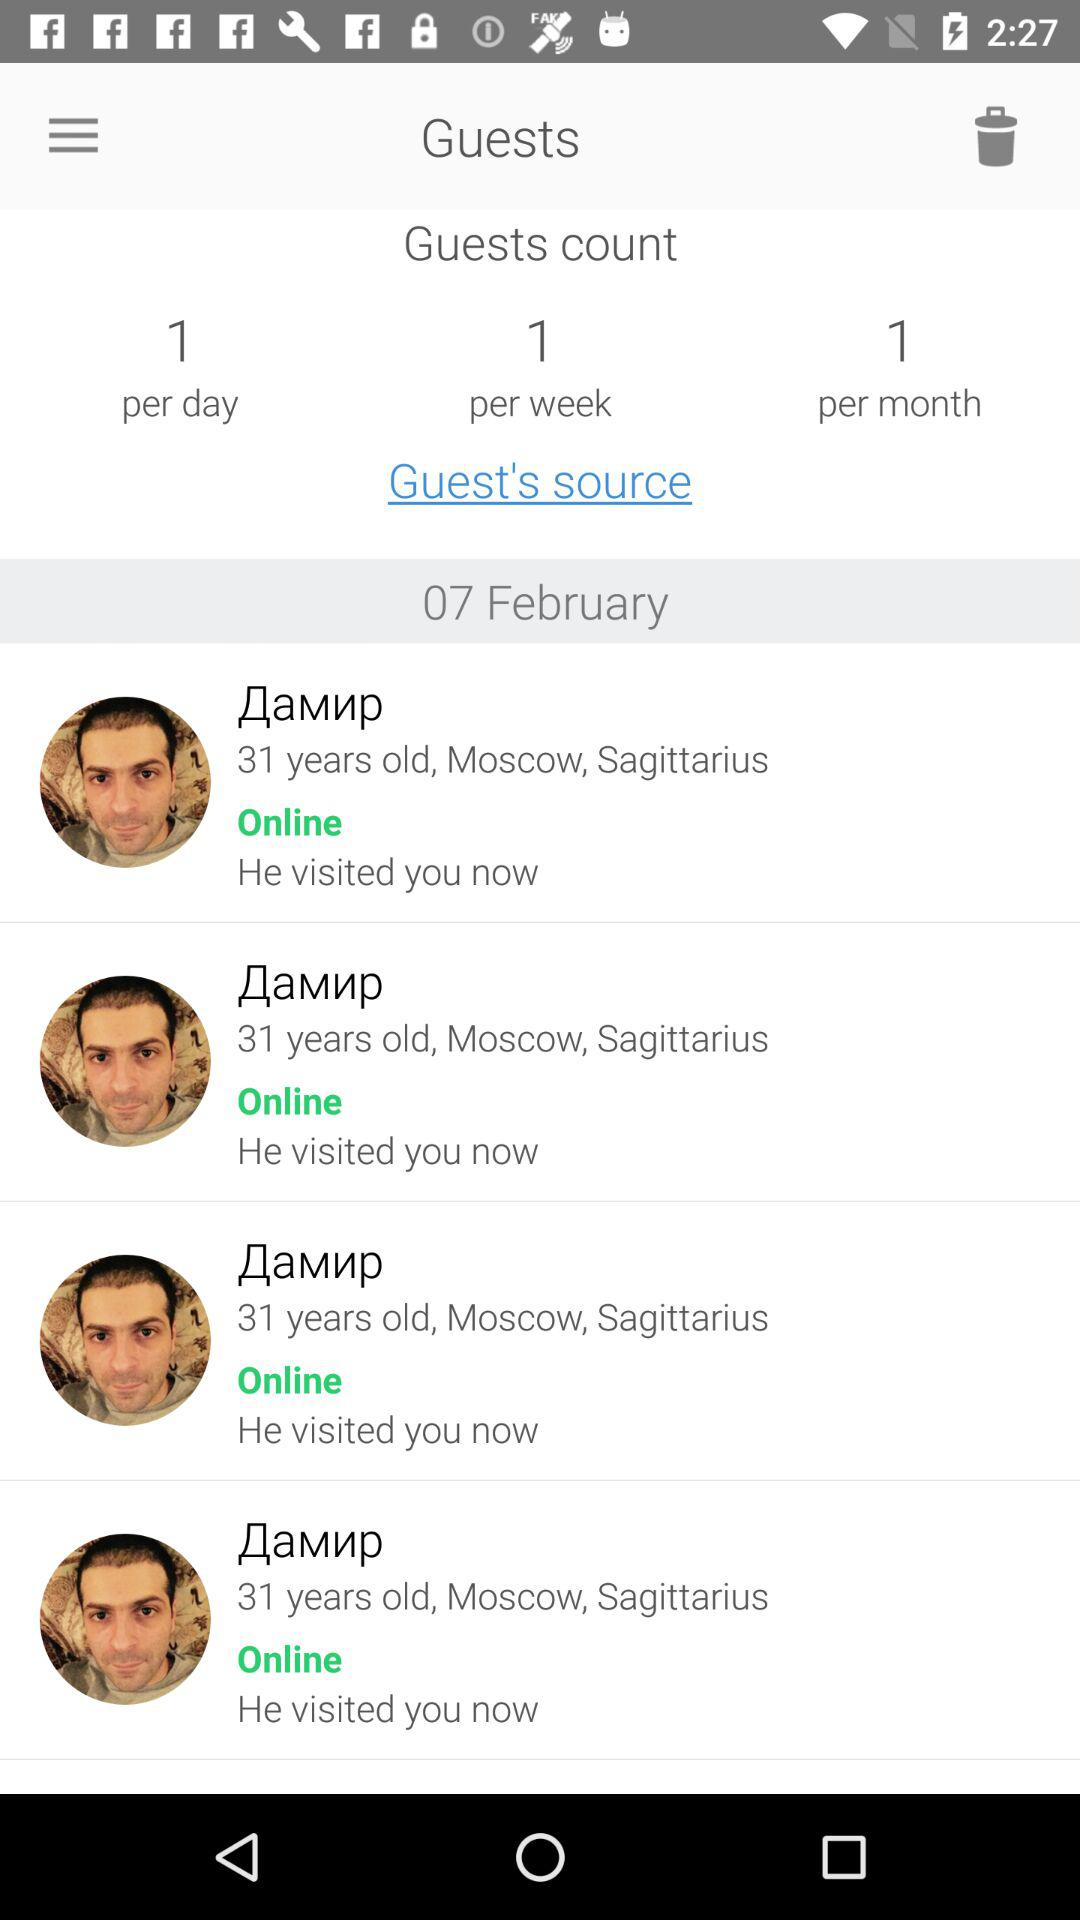What is the city name of the guest? The city name is Moscow. 